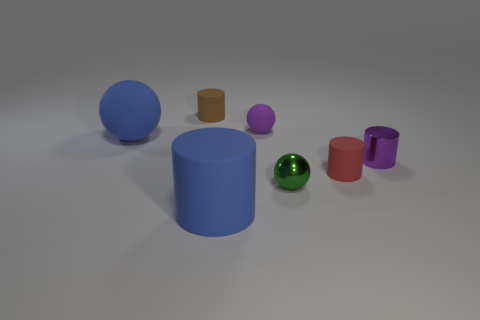How many things are blue rubber cylinders or tiny red matte cylinders? In the image, there is one large blue rubber cylinder and one small red matte cylinder, making a total of two objects that match the description. 